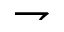Convert formula to latex. <formula><loc_0><loc_0><loc_500><loc_500>\rightharpoondown</formula> 